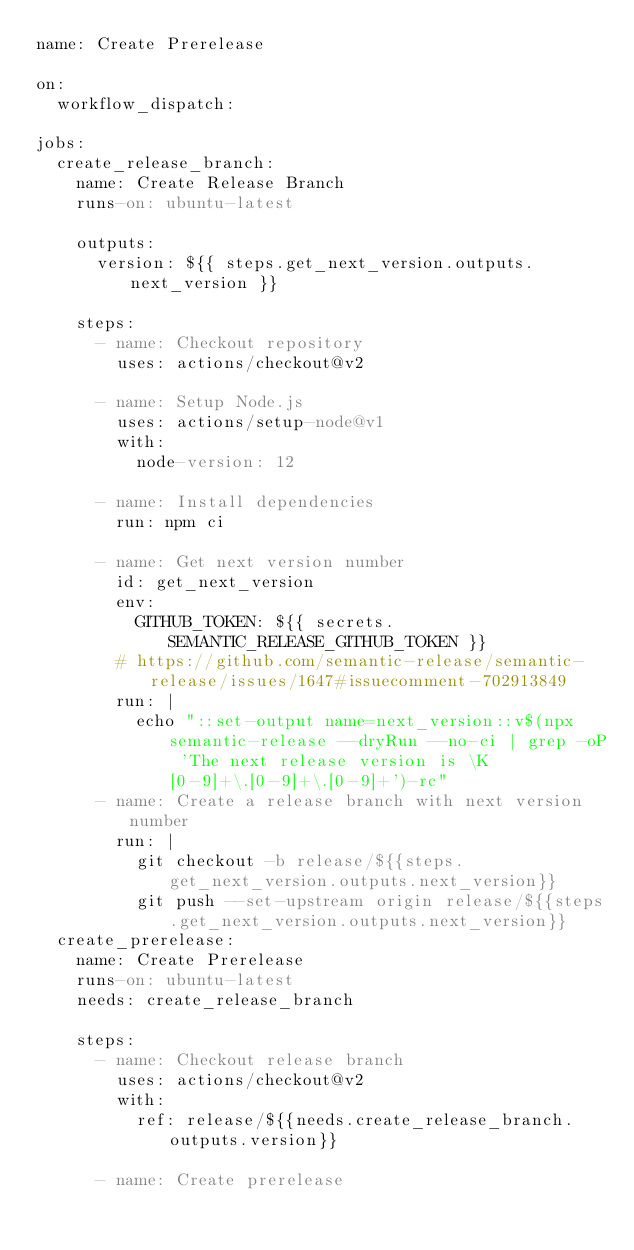Convert code to text. <code><loc_0><loc_0><loc_500><loc_500><_YAML_>name: Create Prerelease

on:
  workflow_dispatch:

jobs:
  create_release_branch:
    name: Create Release Branch
    runs-on: ubuntu-latest

    outputs:
      version: ${{ steps.get_next_version.outputs.next_version }}

    steps:
      - name: Checkout repository
        uses: actions/checkout@v2

      - name: Setup Node.js
        uses: actions/setup-node@v1
        with:
          node-version: 12

      - name: Install dependencies
        run: npm ci

      - name: Get next version number
        id: get_next_version
        env:
          GITHUB_TOKEN: ${{ secrets.SEMANTIC_RELEASE_GITHUB_TOKEN }}
        # https://github.com/semantic-release/semantic-release/issues/1647#issuecomment-702913849
        run: |
          echo "::set-output name=next_version::v$(npx semantic-release --dryRun --no-ci | grep -oP 'The next release version is \K[0-9]+\.[0-9]+\.[0-9]+')-rc"
      - name: Create a release branch with next version number
        run: |
          git checkout -b release/${{steps.get_next_version.outputs.next_version}}
          git push --set-upstream origin release/${{steps.get_next_version.outputs.next_version}}
  create_prerelease:
    name: Create Prerelease
    runs-on: ubuntu-latest
    needs: create_release_branch

    steps:
      - name: Checkout release branch
        uses: actions/checkout@v2
        with:
          ref: release/${{needs.create_release_branch.outputs.version}}

      - name: Create prerelease</code> 